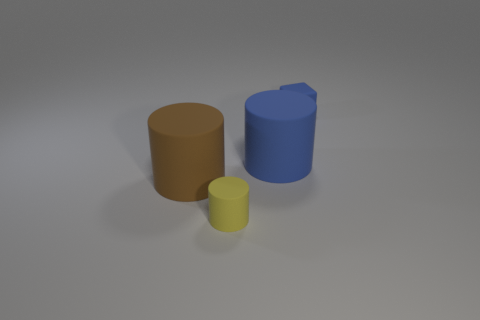What is the size of the brown thing that is the same shape as the big blue rubber thing?
Provide a succinct answer. Large. Are there more large blue cylinders behind the tiny blue cube than rubber things behind the blue matte cylinder?
Offer a very short reply. No. The thing that is right of the yellow matte cylinder and in front of the small block is made of what material?
Provide a succinct answer. Rubber. What is the color of the small matte thing that is the same shape as the big brown thing?
Your response must be concise. Yellow. What is the size of the yellow rubber cylinder?
Provide a succinct answer. Small. What is the color of the big cylinder that is on the left side of the big blue object right of the yellow rubber cylinder?
Provide a succinct answer. Brown. How many cylinders are both right of the brown matte cylinder and in front of the blue rubber cylinder?
Give a very brief answer. 1. Are there more small green cubes than blue cylinders?
Provide a succinct answer. No. What material is the yellow cylinder?
Provide a short and direct response. Rubber. There is a blue matte cylinder behind the big brown matte thing; how many yellow cylinders are behind it?
Ensure brevity in your answer.  0. 